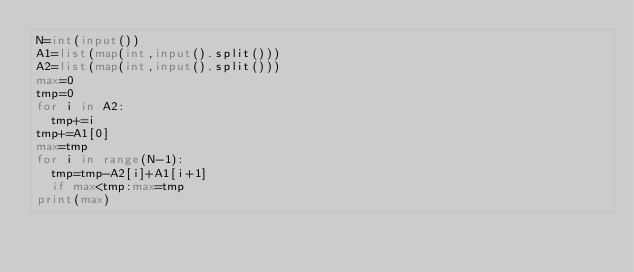<code> <loc_0><loc_0><loc_500><loc_500><_Python_>N=int(input())
A1=list(map(int,input().split()))
A2=list(map(int,input().split()))
max=0
tmp=0
for i in A2:
  tmp+=i
tmp+=A1[0]
max=tmp
for i in range(N-1):
  tmp=tmp-A2[i]+A1[i+1]
  if max<tmp:max=tmp
print(max)</code> 